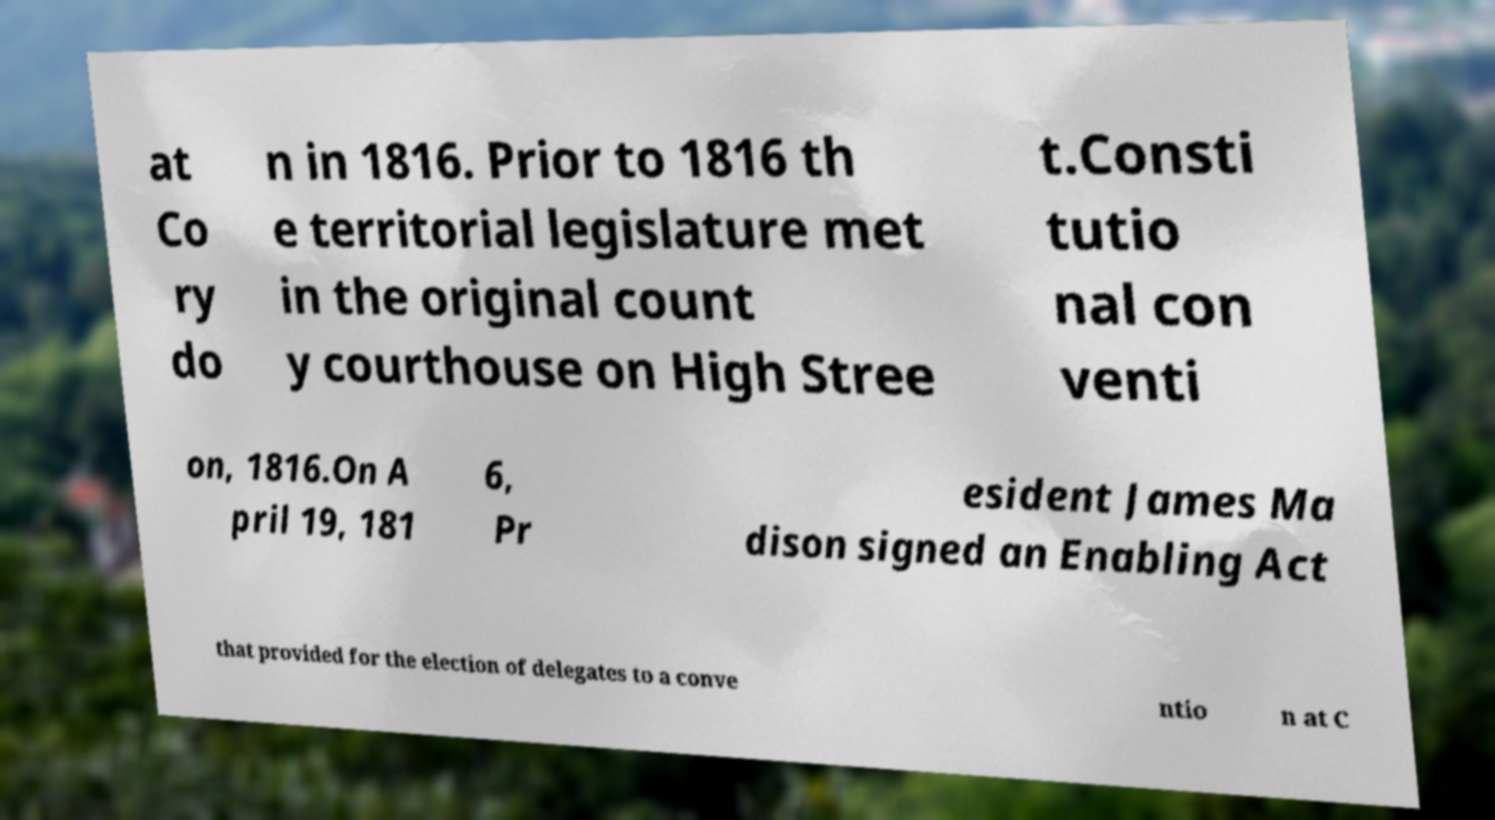There's text embedded in this image that I need extracted. Can you transcribe it verbatim? at Co ry do n in 1816. Prior to 1816 th e territorial legislature met in the original count y courthouse on High Stree t.Consti tutio nal con venti on, 1816.On A pril 19, 181 6, Pr esident James Ma dison signed an Enabling Act that provided for the election of delegates to a conve ntio n at C 